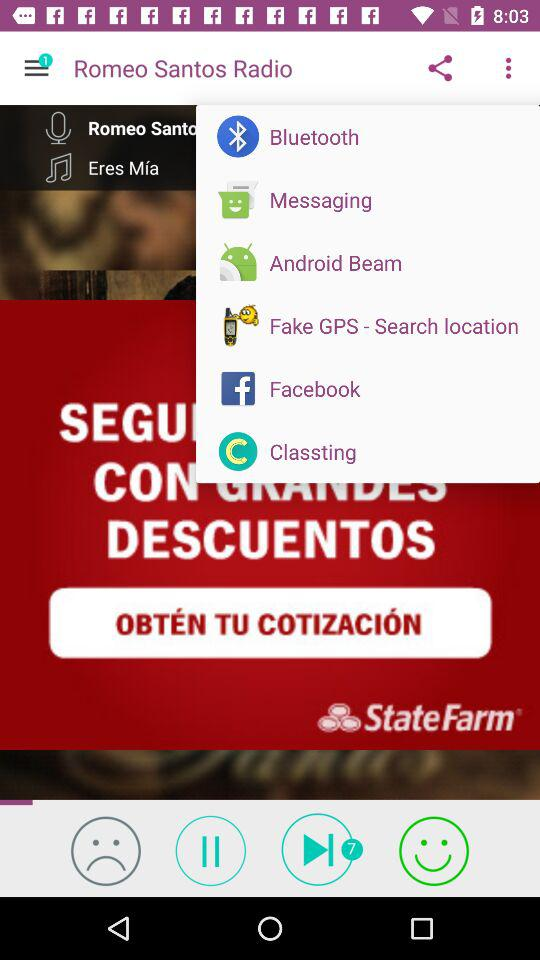Through which application can we share the playlist? You can share through "Bluetooth", "Messaging", "Android Beam", "Fake GPS - Search location", "Facebook" and "Classting". 